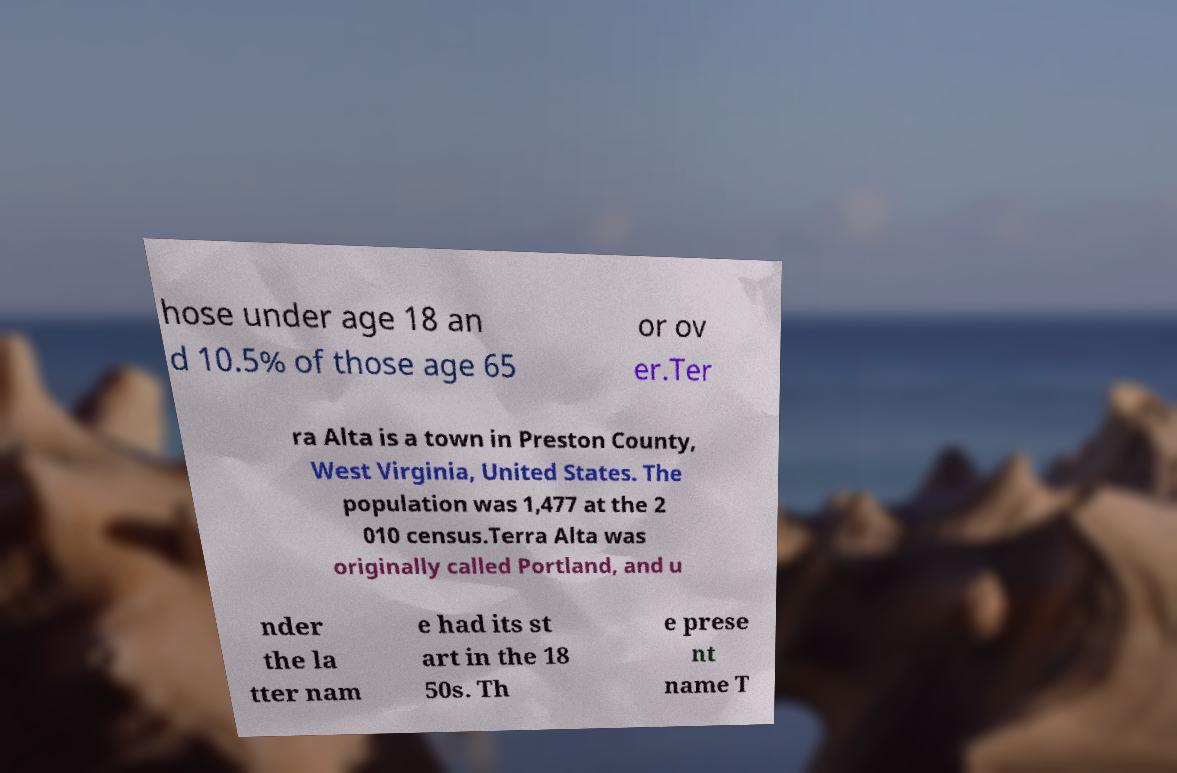Can you accurately transcribe the text from the provided image for me? hose under age 18 an d 10.5% of those age 65 or ov er.Ter ra Alta is a town in Preston County, West Virginia, United States. The population was 1,477 at the 2 010 census.Terra Alta was originally called Portland, and u nder the la tter nam e had its st art in the 18 50s. Th e prese nt name T 